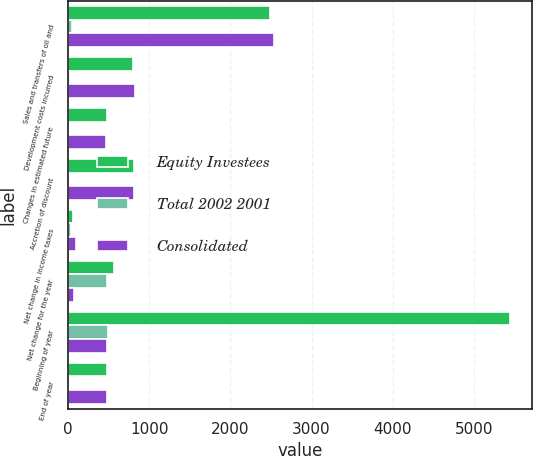Convert chart. <chart><loc_0><loc_0><loc_500><loc_500><stacked_bar_chart><ecel><fcel>Sales and transfers of oil and<fcel>Development costs incurred<fcel>Changes in estimated future<fcel>Accretion of discount<fcel>Net change in income taxes<fcel>Net change for the year<fcel>Beginning of year<fcel>End of year<nl><fcel>Equity Investees<fcel>2487<fcel>802<fcel>478<fcel>807<fcel>65<fcel>560<fcel>5441<fcel>478<nl><fcel>Total 2002 2001<fcel>49<fcel>20<fcel>10<fcel>6<fcel>29<fcel>484<fcel>492<fcel>8<nl><fcel>Consolidated<fcel>2536<fcel>822<fcel>468<fcel>813<fcel>94<fcel>76<fcel>478<fcel>478<nl></chart> 